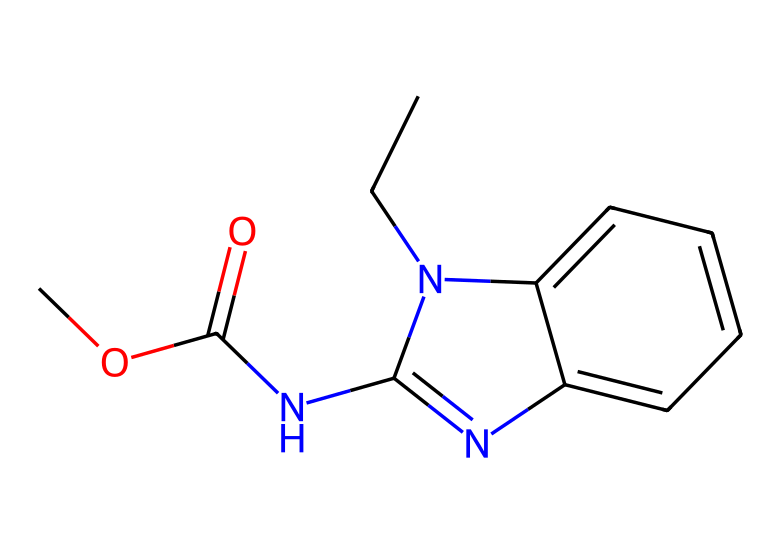What is the main functional group in carbendazim? The functional group can be identified by looking for characteristic groups in the structure. The structure shows a carbonyl group (C=O) which is part of the ester. Therefore, the main functional group is the ester functional group.
Answer: ester How many nitrogen atoms are present in the structure of carbendazim? The structure can be analyzed for nitrogen atoms by counting the occurrences of the nitrogen symbol "N" in the SMILES representation. The chemical contains two nitrogen atoms, one in the ring structure and the other connected to the carbon chain.
Answer: two What type of bonds are predominantly found in carbendazim? The types of bonds in the structure can be determined by analyzing the connections between atoms. The chemical contains single (C-C, C-N), double (C=N, C=O), and possibly aromatic bonds (C-C in benzene rings), but the most frequent bond type is single bonds.
Answer: single Is carbendazim likely to have a high or low solubility in water? To assess solubility, we consider the presence of polar functional groups and overall structure. Carbendazim contains an ester and amine groups, indicating some polar functionality, which contributes to moderate solubility in water, but the aromatic nature suggests it may lean towards low solubility.
Answer: low What is the role of carbendazim in agriculture? The purpose of carbendazim as a chemical can be inferred from its classification as a fungicide. This indicates that its role is to control fungal diseases on crops, serving as a protective agent for various plants.
Answer: fungicide What characteristic features suggest carbendazim is a systemic fungicide? Systemic fungicides are typically designed to be absorbed and translocated throughout the plant. The presence of a molecular structure that allows penetration through plant tissues (like a relatively small and polar structure) implies it is a systemic. This structure suggests it can effectively be transported within plant systems.
Answer: systemic 